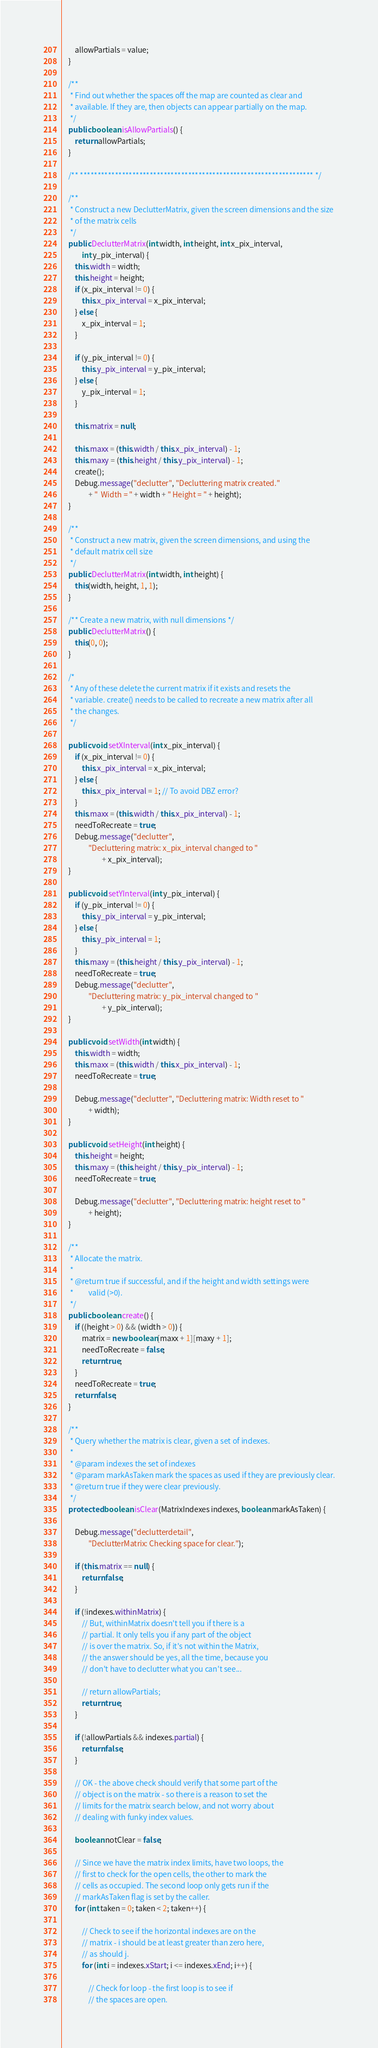Convert code to text. <code><loc_0><loc_0><loc_500><loc_500><_Java_>        allowPartials = value;
    }

    /**
     * Find out whether the spaces off the map are counted as clear and
     * available. If they are, then objects can appear partially on the map.
     */
    public boolean isAllowPartials() {
        return allowPartials;
    }

    /** ******************************************************************* */

    /**
     * Construct a new DeclutterMatrix, given the screen dimensions and the size
     * of the matrix cells
     */
    public DeclutterMatrix(int width, int height, int x_pix_interval,
            int y_pix_interval) {
        this.width = width;
        this.height = height;
        if (x_pix_interval != 0) {
            this.x_pix_interval = x_pix_interval;
        } else {
            x_pix_interval = 1;
        }

        if (y_pix_interval != 0) {
            this.y_pix_interval = y_pix_interval;
        } else {
            y_pix_interval = 1;
        }

        this.matrix = null;

        this.maxx = (this.width / this.x_pix_interval) - 1;
        this.maxy = (this.height / this.y_pix_interval) - 1;
        create();
        Debug.message("declutter", "Decluttering matrix created."
                + "  Width = " + width + " Height = " + height);
    }

    /**
     * Construct a new matrix, given the screen dimensions, and using the
     * default matrix cell size
     */
    public DeclutterMatrix(int width, int height) {
        this(width, height, 1, 1);
    }

    /** Create a new matrix, with null dimensions */
    public DeclutterMatrix() {
        this(0, 0);
    }

    /*
     * Any of these delete the current matrix if it exists and resets the
     * variable. create() needs to be called to recreate a new matrix after all
     * the changes.
     */

    public void setXInterval(int x_pix_interval) {
        if (x_pix_interval != 0) {
            this.x_pix_interval = x_pix_interval;
        } else {
            this.x_pix_interval = 1; // To avoid DBZ error?
        }
        this.maxx = (this.width / this.x_pix_interval) - 1;
        needToRecreate = true;
        Debug.message("declutter",
                "Decluttering matrix: x_pix_interval changed to "
                        + x_pix_interval);
    }

    public void setYInterval(int y_pix_interval) {
        if (y_pix_interval != 0) {
            this.y_pix_interval = y_pix_interval;
        } else {
            this.y_pix_interval = 1;
        }
        this.maxy = (this.height / this.y_pix_interval) - 1;
        needToRecreate = true;
        Debug.message("declutter",
                "Decluttering matrix: y_pix_interval changed to "
                        + y_pix_interval);
    }

    public void setWidth(int width) {
        this.width = width;
        this.maxx = (this.width / this.x_pix_interval) - 1;
        needToRecreate = true;

        Debug.message("declutter", "Decluttering matrix: Width reset to "
                + width);
    }

    public void setHeight(int height) {
        this.height = height;
        this.maxy = (this.height / this.y_pix_interval) - 1;
        needToRecreate = true;

        Debug.message("declutter", "Decluttering matrix: height reset to "
                + height);
    }

    /**
     * Allocate the matrix.
     * 
     * @return true if successful, and if the height and width settings were
     *         valid (>0).
     */
    public boolean create() {
        if ((height > 0) && (width > 0)) {
            matrix = new boolean[maxx + 1][maxy + 1];
            needToRecreate = false;
            return true;
        }
        needToRecreate = true;
        return false;
    }

    /**
     * Query whether the matrix is clear, given a set of indexes.
     * 
     * @param indexes the set of indexes
     * @param markAsTaken mark the spaces as used if they are previously clear.
     * @return true if they were clear previously.
     */
    protected boolean isClear(MatrixIndexes indexes, boolean markAsTaken) {

        Debug.message("declutterdetail",
                "DeclutterMatrix: Checking space for clear.");

        if (this.matrix == null) {
            return false;
        }

        if (!indexes.withinMatrix) {
            // But, withinMatrix doesn't tell you if there is a
            // partial. It only tells you if any part of the object
            // is over the matrix. So, if it's not within the Matrix,
            // the answer should be yes, all the time, because you
            // don't have to declutter what you can't see...

            // return allowPartials;
            return true;
        }

        if (!allowPartials && indexes.partial) {
            return false;
        }

        // OK - the above check should verify that some part of the
        // object is on the matrix - so there is a reason to set the
        // limits for the matrix search below, and not worry about
        // dealing with funky index values.

        boolean notClear = false;

        // Since we have the matrix index limits, have two loops, the
        // first to check for the open cells, the other to mark the
        // cells as occupied. The second loop only gets run if the
        // markAsTaken flag is set by the caller.
        for (int taken = 0; taken < 2; taken++) {

            // Check to see if the horizontal indexes are on the
            // matrix - i should be at least greater than zero here,
            // as should j.
            for (int i = indexes.xStart; i <= indexes.xEnd; i++) {

                // Check for loop - the first loop is to see if
                // the spaces are open.</code> 